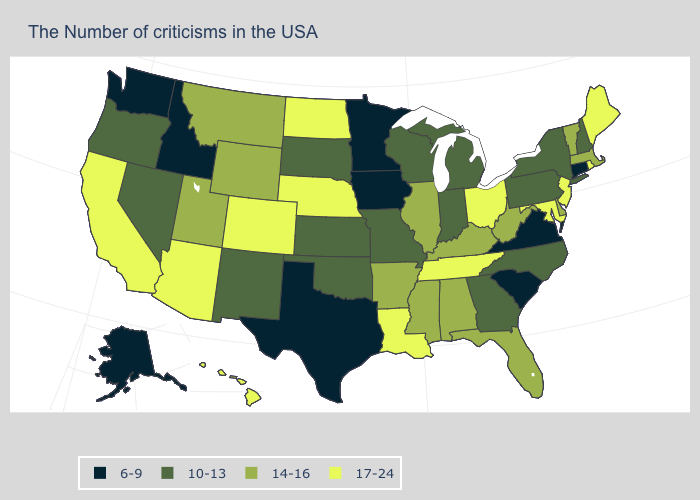What is the value of Maryland?
Be succinct. 17-24. What is the value of North Dakota?
Quick response, please. 17-24. Which states have the lowest value in the MidWest?
Quick response, please. Minnesota, Iowa. Among the states that border Michigan , which have the lowest value?
Short answer required. Indiana, Wisconsin. Does the first symbol in the legend represent the smallest category?
Write a very short answer. Yes. Which states have the lowest value in the USA?
Be succinct. Connecticut, Virginia, South Carolina, Minnesota, Iowa, Texas, Idaho, Washington, Alaska. Name the states that have a value in the range 14-16?
Keep it brief. Massachusetts, Vermont, Delaware, West Virginia, Florida, Kentucky, Alabama, Illinois, Mississippi, Arkansas, Wyoming, Utah, Montana. Does New Jersey have the same value as Massachusetts?
Be succinct. No. What is the lowest value in the West?
Quick response, please. 6-9. Which states have the lowest value in the USA?
Quick response, please. Connecticut, Virginia, South Carolina, Minnesota, Iowa, Texas, Idaho, Washington, Alaska. How many symbols are there in the legend?
Keep it brief. 4. Name the states that have a value in the range 14-16?
Give a very brief answer. Massachusetts, Vermont, Delaware, West Virginia, Florida, Kentucky, Alabama, Illinois, Mississippi, Arkansas, Wyoming, Utah, Montana. What is the value of Wyoming?
Keep it brief. 14-16. What is the highest value in states that border South Carolina?
Short answer required. 10-13. Is the legend a continuous bar?
Short answer required. No. 